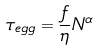Convert formula to latex. <formula><loc_0><loc_0><loc_500><loc_500>\tau _ { e g g } = \frac { f } { \eta } N ^ { \alpha }</formula> 